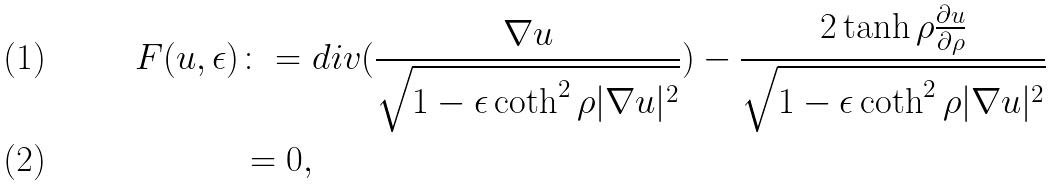<formula> <loc_0><loc_0><loc_500><loc_500>F ( u , \epsilon ) & \colon = d i v ( \frac { \nabla u } { \sqrt { 1 - \epsilon \coth ^ { 2 } \rho | \nabla u | ^ { 2 } } } ) - \frac { 2 \tanh \rho \frac { \partial u } { \partial \rho } } { \sqrt { 1 - \epsilon \coth ^ { 2 } \rho | \nabla u | ^ { 2 } } } \\ & = 0 ,</formula> 